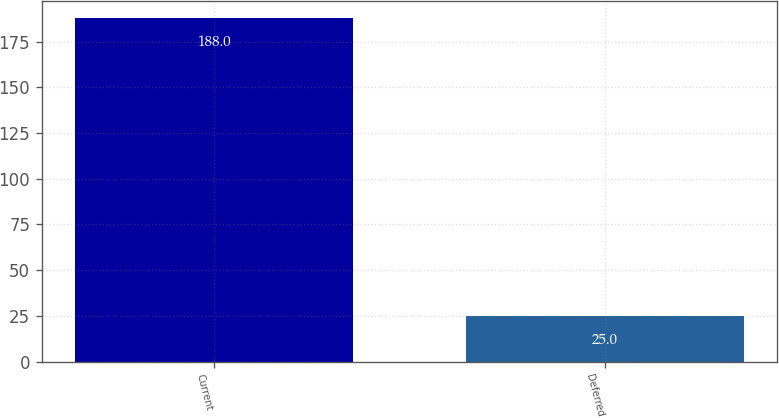Convert chart to OTSL. <chart><loc_0><loc_0><loc_500><loc_500><bar_chart><fcel>Current<fcel>Deferred<nl><fcel>188<fcel>25<nl></chart> 